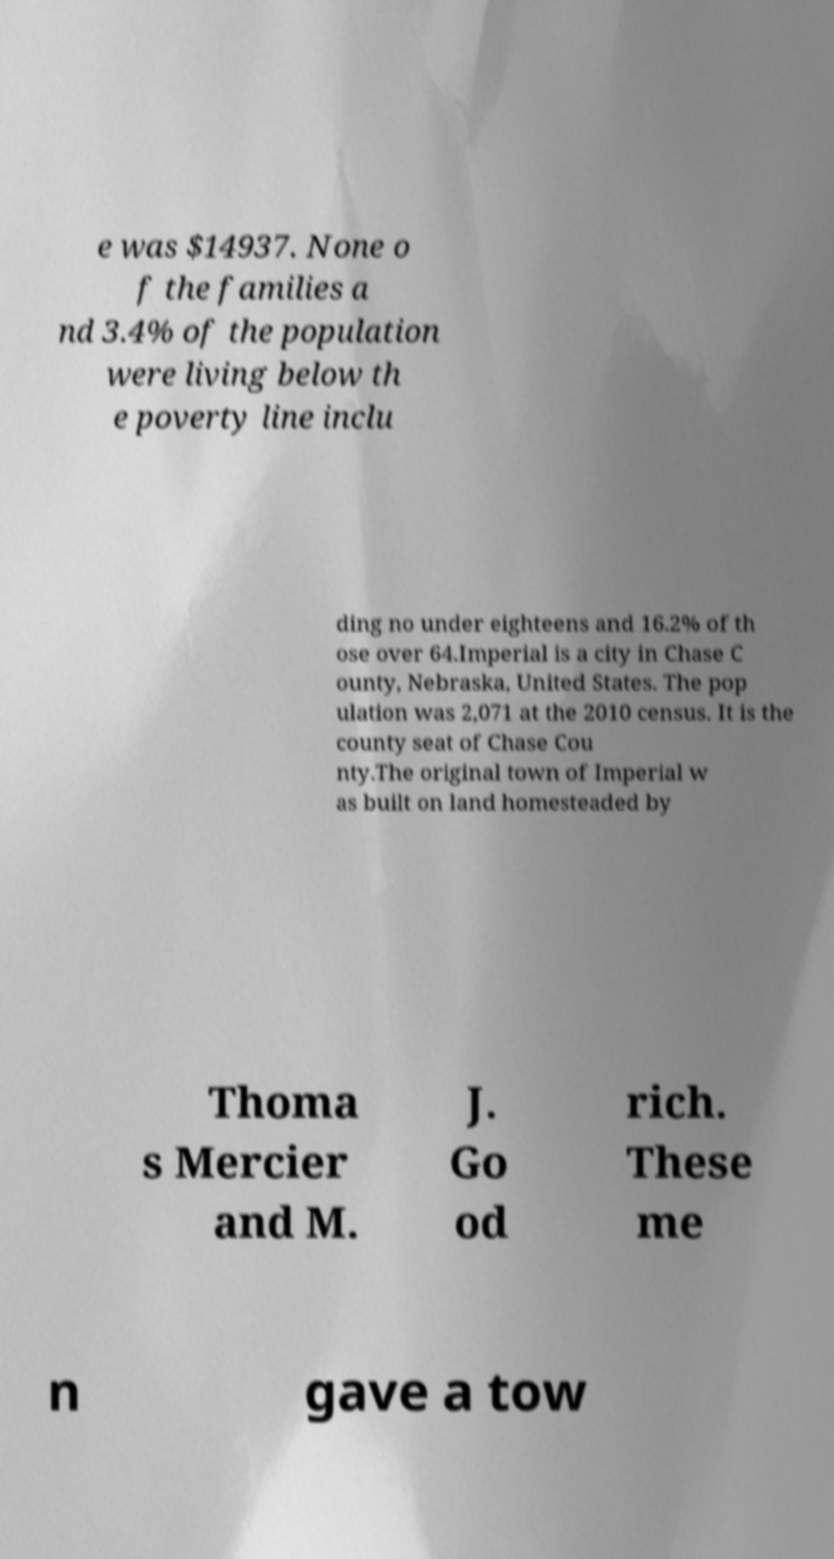For documentation purposes, I need the text within this image transcribed. Could you provide that? e was $14937. None o f the families a nd 3.4% of the population were living below th e poverty line inclu ding no under eighteens and 16.2% of th ose over 64.Imperial is a city in Chase C ounty, Nebraska, United States. The pop ulation was 2,071 at the 2010 census. It is the county seat of Chase Cou nty.The original town of Imperial w as built on land homesteaded by Thoma s Mercier and M. J. Go od rich. These me n gave a tow 